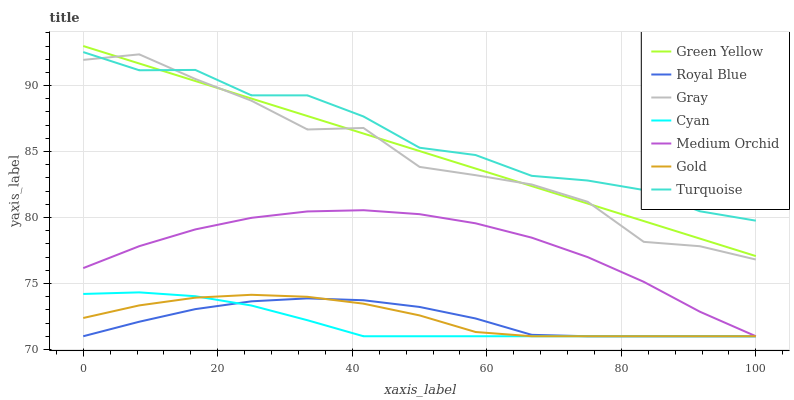Does Cyan have the minimum area under the curve?
Answer yes or no. Yes. Does Turquoise have the maximum area under the curve?
Answer yes or no. Yes. Does Gold have the minimum area under the curve?
Answer yes or no. No. Does Gold have the maximum area under the curve?
Answer yes or no. No. Is Green Yellow the smoothest?
Answer yes or no. Yes. Is Gray the roughest?
Answer yes or no. Yes. Is Turquoise the smoothest?
Answer yes or no. No. Is Turquoise the roughest?
Answer yes or no. No. Does Gold have the lowest value?
Answer yes or no. Yes. Does Turquoise have the lowest value?
Answer yes or no. No. Does Green Yellow have the highest value?
Answer yes or no. Yes. Does Turquoise have the highest value?
Answer yes or no. No. Is Royal Blue less than Turquoise?
Answer yes or no. Yes. Is Turquoise greater than Medium Orchid?
Answer yes or no. Yes. Does Turquoise intersect Gray?
Answer yes or no. Yes. Is Turquoise less than Gray?
Answer yes or no. No. Is Turquoise greater than Gray?
Answer yes or no. No. Does Royal Blue intersect Turquoise?
Answer yes or no. No. 